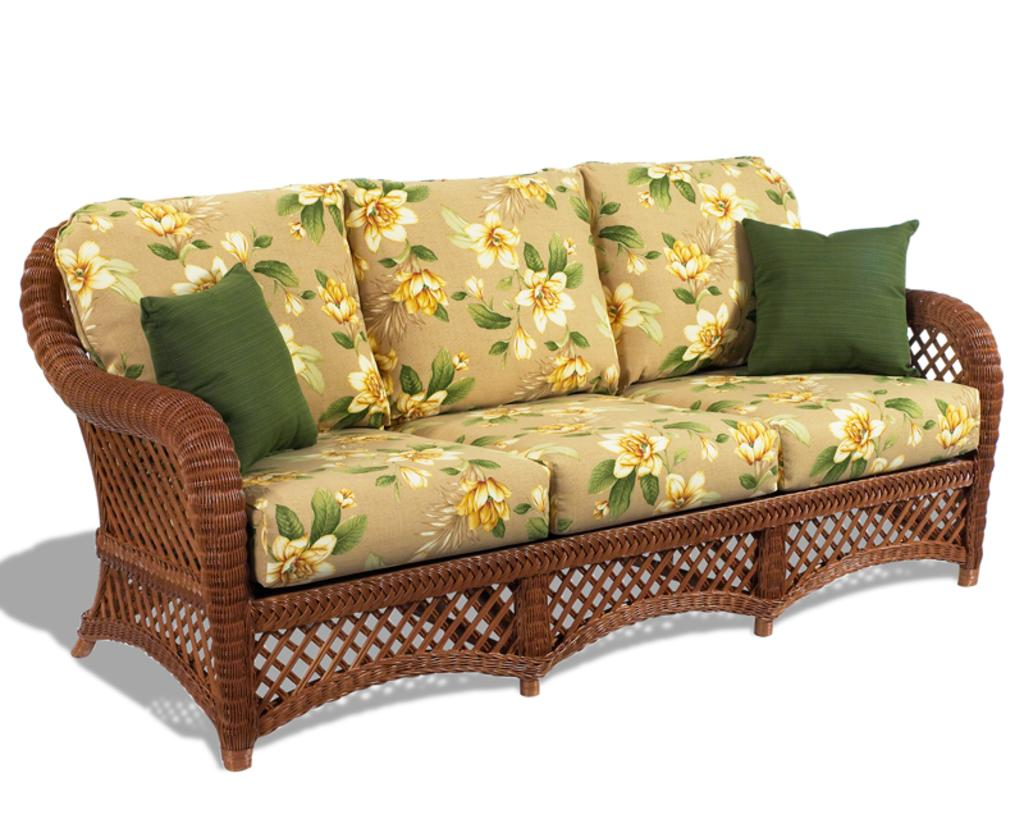What is the main piece of furniture in the center of the picture? There is a couch in the center of the picture. What is placed on the couch? There are pillows on the couch. What is the moon doing in the picture? The moon is not present in the picture; it is a celestial body. 